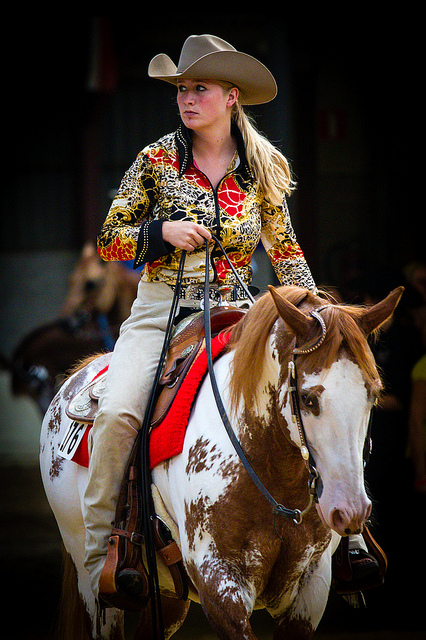How many zebra are here? 0 